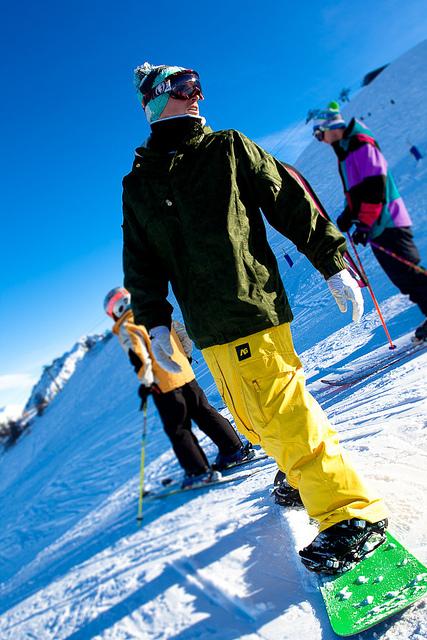What color is the snowboard?
Write a very short answer. Green. What color are the man's pants?
Answer briefly. Yellow. Is this a summer destination?
Quick response, please. No. 